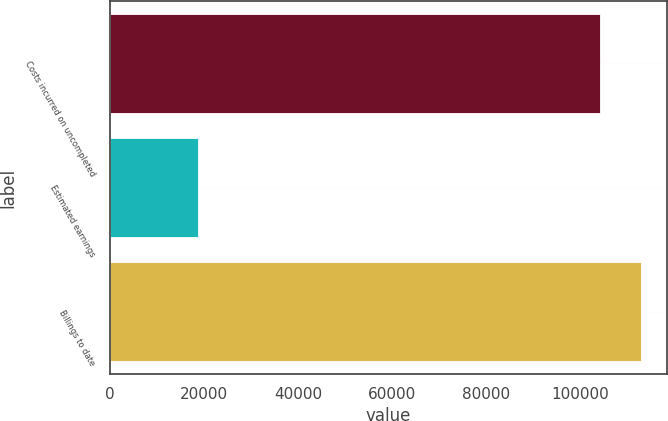Convert chart to OTSL. <chart><loc_0><loc_0><loc_500><loc_500><bar_chart><fcel>Costs incurred on uncompleted<fcel>Estimated earnings<fcel>Billings to date<nl><fcel>104157<fcel>18771<fcel>112738<nl></chart> 